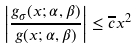<formula> <loc_0><loc_0><loc_500><loc_500>\left | \frac { g _ { \sigma } ( x ; \alpha , \beta ) } { g ( x ; \alpha , \beta ) } \right | \leq \overline { c } x ^ { 2 }</formula> 